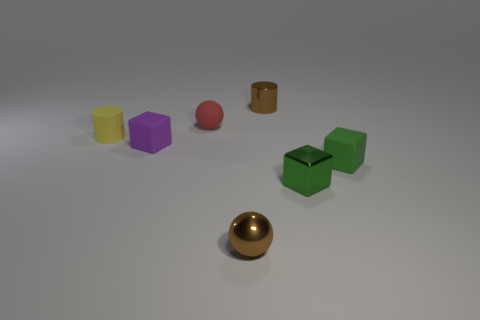There is a green thing that is the same material as the brown ball; what is its size?
Make the answer very short. Small. What is the shape of the brown object on the right side of the tiny brown thing on the left side of the brown shiny thing that is behind the yellow cylinder?
Your answer should be very brief. Cylinder. The brown metal thing that is the same shape as the tiny red thing is what size?
Provide a short and direct response. Small. There is a object that is both to the left of the tiny brown cylinder and in front of the purple block; what is its size?
Ensure brevity in your answer.  Small. There is a metal thing that is the same color as the small shiny cylinder; what shape is it?
Offer a terse response. Sphere. The tiny metal block is what color?
Provide a succinct answer. Green. How big is the metallic cylinder to the left of the small green matte block?
Offer a terse response. Small. There is a brown metallic thing that is in front of the cylinder that is left of the red object; what number of tiny green metallic cubes are in front of it?
Provide a short and direct response. 0. What color is the small cylinder on the left side of the tiny metal object that is behind the green matte cube?
Ensure brevity in your answer.  Yellow. Is there a yellow cylinder that has the same size as the purple cube?
Your answer should be very brief. Yes. 